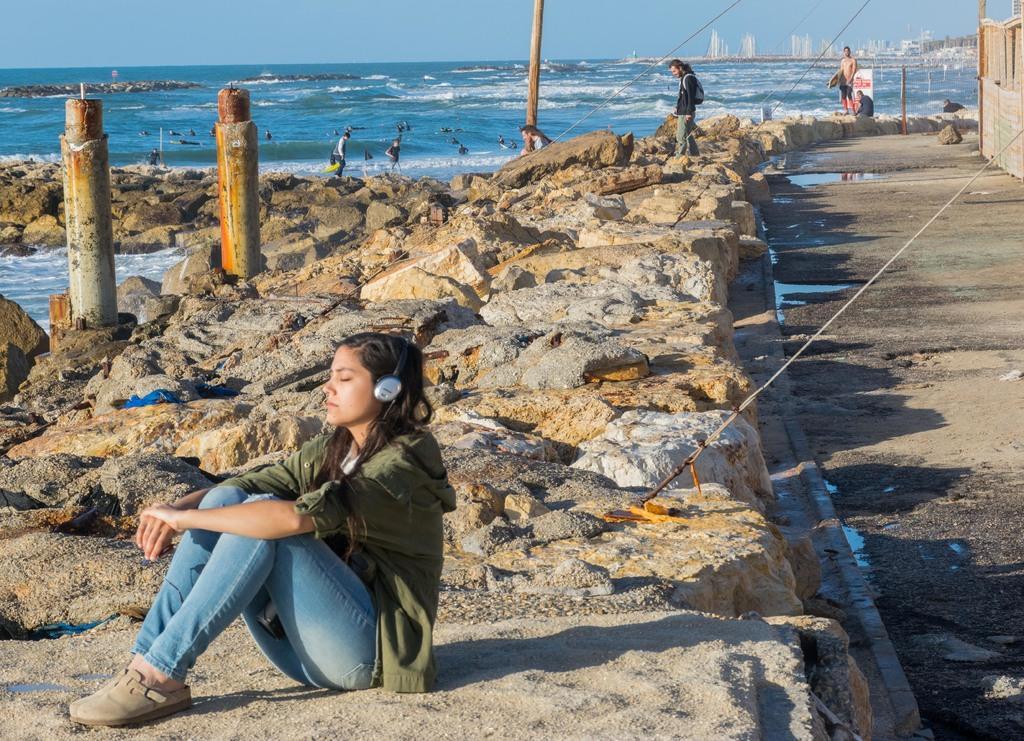How would you summarize this image in a sentence or two? In this picture I can see there is a woman sitting on the rocks and listening to music and there are few other people standing and sitting on the rocks and there is a ocean on to left and there are few buildings in the backdrop. 